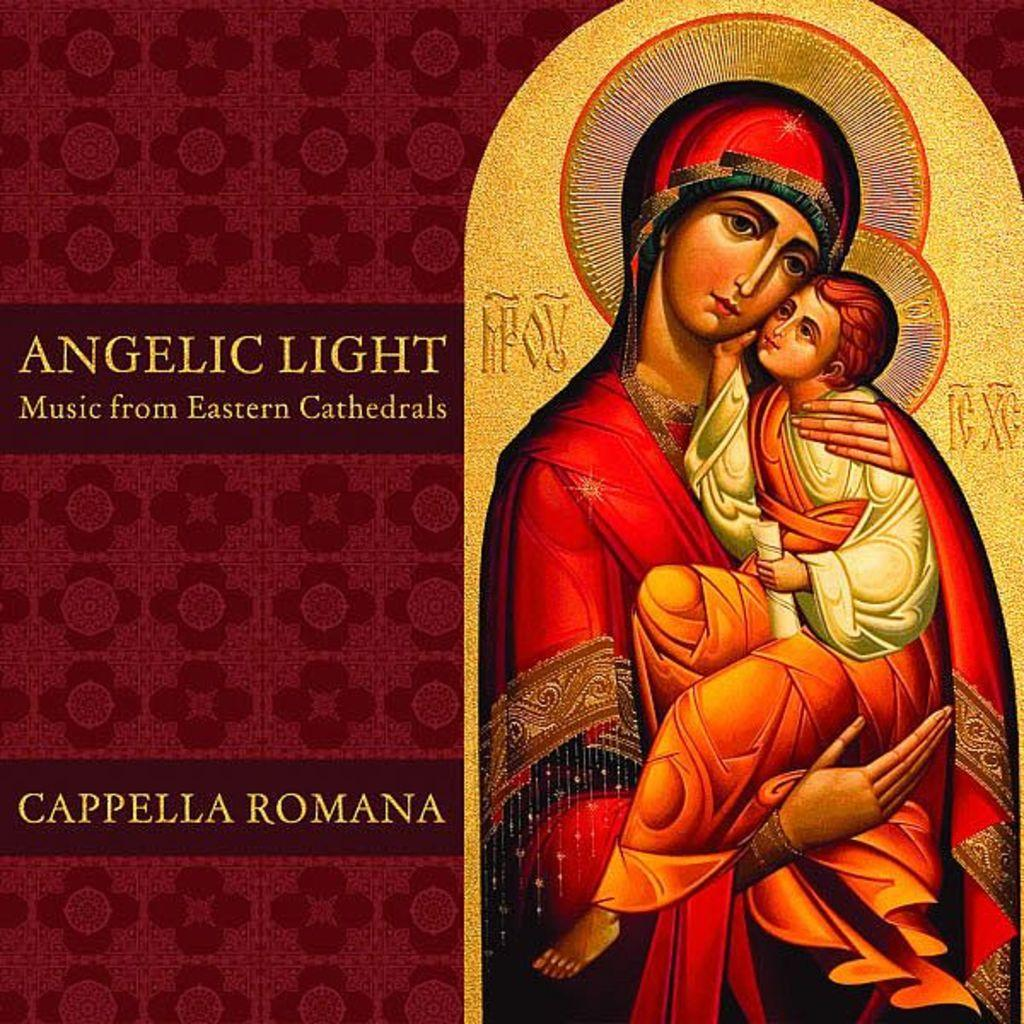What is present in the image that features a visual representation? There is a poster in the image. What can be seen on the poster? The poster contains the depiction of persons. Are there any words or phrases on the poster? Yes, the poster includes text. How many bikes are shown in the poster? There is no mention of bikes in the image or the provided facts, so it cannot be determined if any bikes are present. 